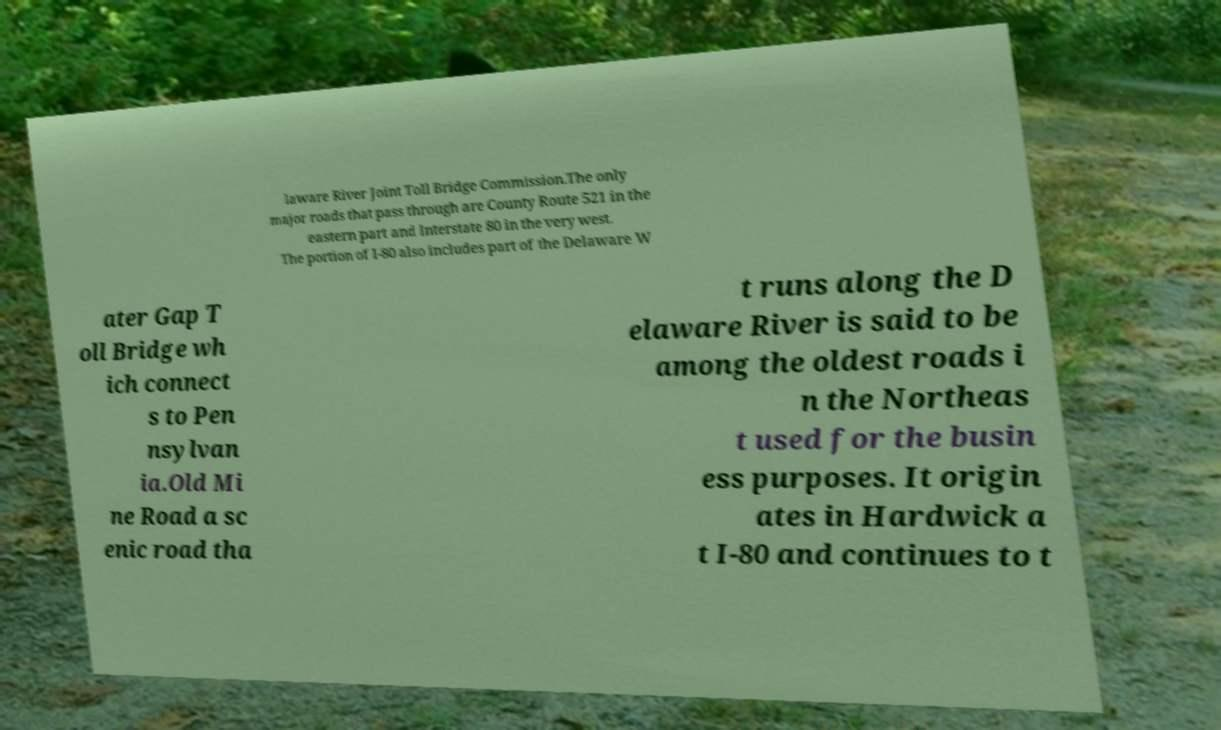Can you read and provide the text displayed in the image?This photo seems to have some interesting text. Can you extract and type it out for me? laware River Joint Toll Bridge Commission.The only major roads that pass through are County Route 521 in the eastern part and Interstate 80 in the very west. The portion of I-80 also includes part of the Delaware W ater Gap T oll Bridge wh ich connect s to Pen nsylvan ia.Old Mi ne Road a sc enic road tha t runs along the D elaware River is said to be among the oldest roads i n the Northeas t used for the busin ess purposes. It origin ates in Hardwick a t I-80 and continues to t 